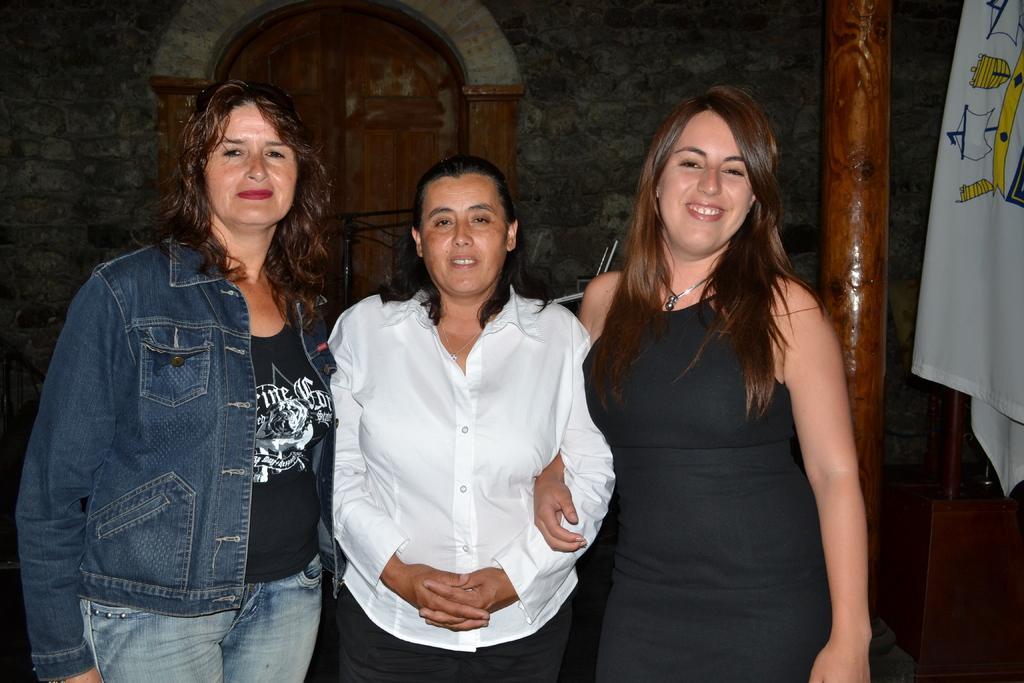Describe this image in one or two sentences. In this picture there are ladies in the center of the image and there is a door in the background area of the image, there is a pillar on the right side of the image. 